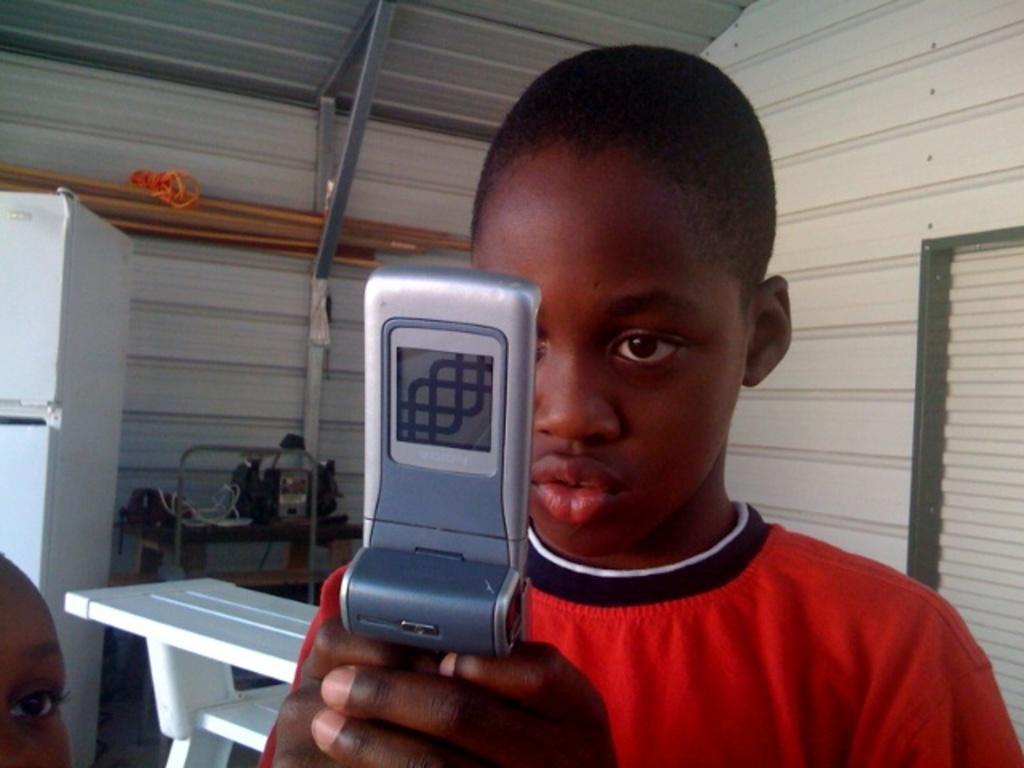In one or two sentences, can you explain what this image depicts? There is a kid holding a mobile, beside this kid we can see a person face. In the background we can see table, white object, wall, rods and objects on the table. 